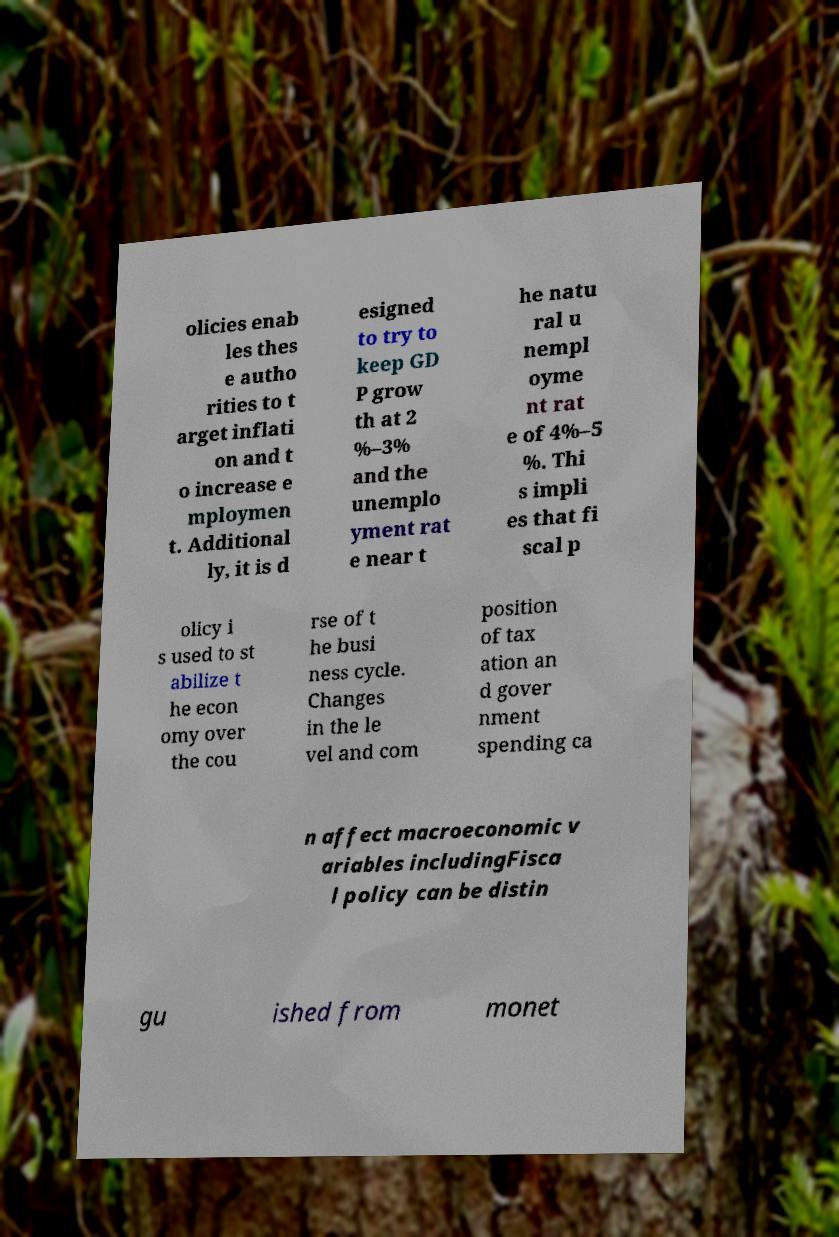Can you accurately transcribe the text from the provided image for me? olicies enab les thes e autho rities to t arget inflati on and t o increase e mploymen t. Additional ly, it is d esigned to try to keep GD P grow th at 2 %–3% and the unemplo yment rat e near t he natu ral u nempl oyme nt rat e of 4%–5 %. Thi s impli es that fi scal p olicy i s used to st abilize t he econ omy over the cou rse of t he busi ness cycle. Changes in the le vel and com position of tax ation an d gover nment spending ca n affect macroeconomic v ariables includingFisca l policy can be distin gu ished from monet 